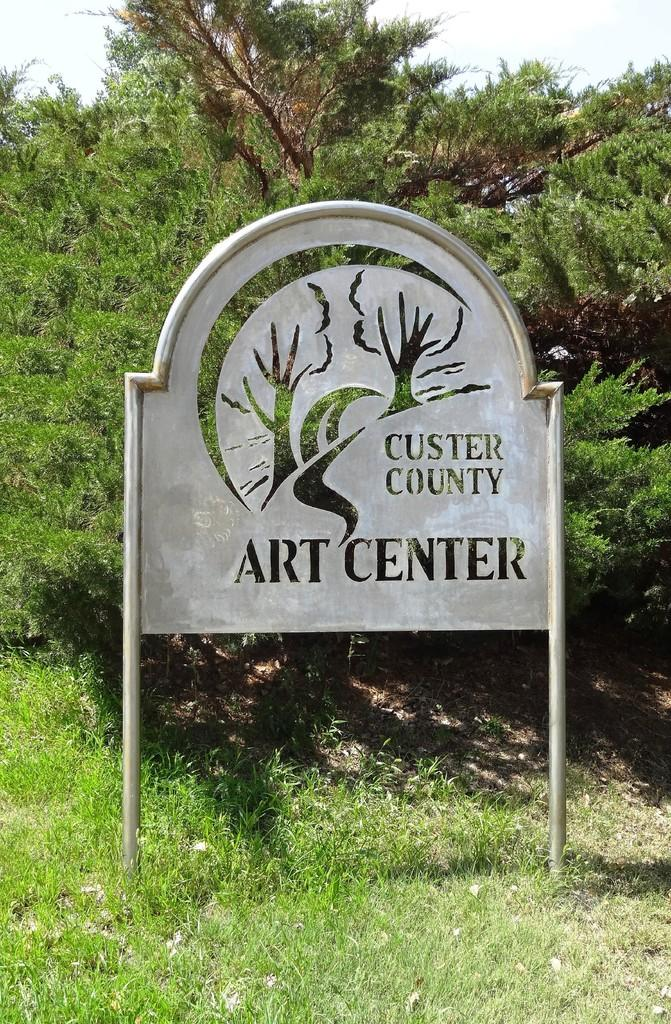What is on the board that is visible in the image? There is a board with writing in the image. What can be seen in the background of the image? There are trees, grass, and the sky visible in the background of the image. Reasoning: Let's think step by step by following the guidelines provided. We start by identifying the main subject in the image, which is the board with writing. Then, we expand the conversation to include other elements that are also visible, such as the trees, grass, and sky in the background. Each question is designed to elicit a specific detail about the image that is known from the provided facts. Absurd Question/Answer: Is there an umbrella being used to protect from the rain in the image? There is no mention of rain or an umbrella in the image. 